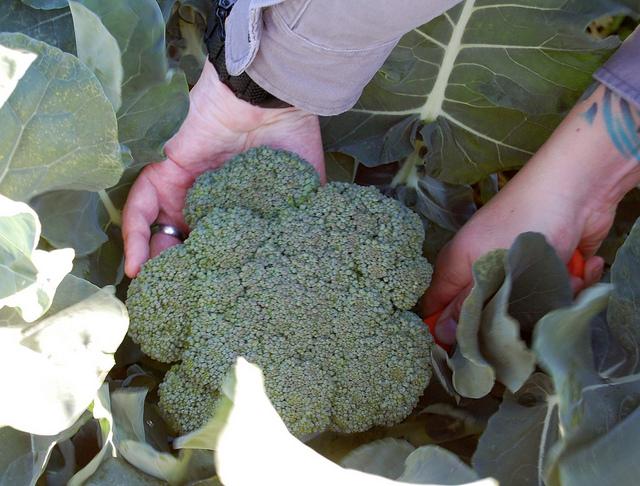Is there a ring on any of the fingers?
Be succinct. Yes. Does the person pictured have a tattoo?
Give a very brief answer. Yes. Are the shirt cuffs buttoned or unbuttoned?
Short answer required. Buttoned. 